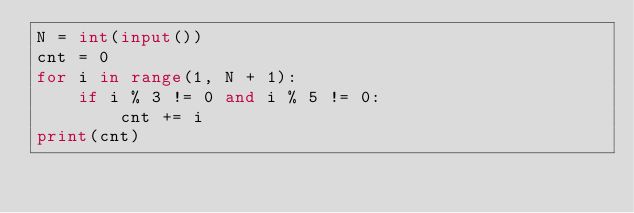<code> <loc_0><loc_0><loc_500><loc_500><_Python_>N = int(input())
cnt = 0
for i in range(1, N + 1):
    if i % 3 != 0 and i % 5 != 0:
        cnt += i
print(cnt)</code> 